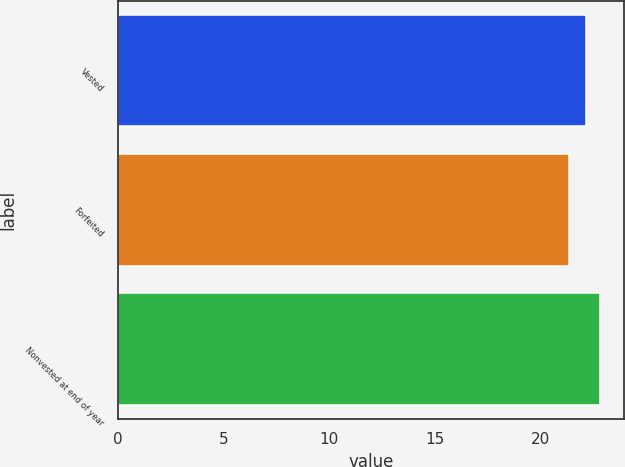Convert chart to OTSL. <chart><loc_0><loc_0><loc_500><loc_500><bar_chart><fcel>Vested<fcel>Forfeited<fcel>Nonvested at end of year<nl><fcel>22.15<fcel>21.35<fcel>22.84<nl></chart> 